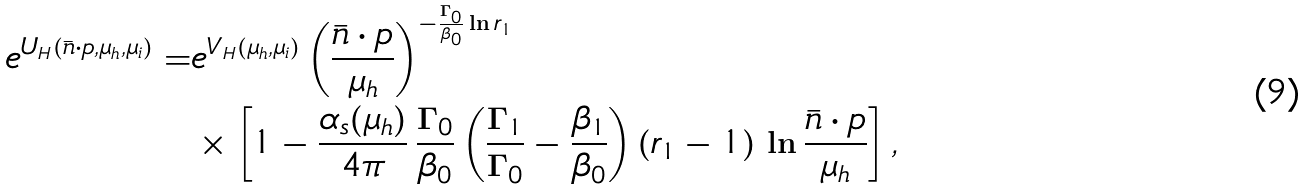<formula> <loc_0><loc_0><loc_500><loc_500>e ^ { U _ { H } ( \bar { n } \cdot p , \mu _ { h } , \mu _ { i } ) } = & e ^ { V _ { H } ( \mu _ { h } , \mu _ { i } ) } \left ( \frac { \bar { n } \cdot p } { \mu _ { h } } \right ) ^ { - \frac { \Gamma _ { 0 } } { \beta _ { 0 } } \ln r _ { 1 } } \\ & \times \left [ 1 - \frac { \alpha _ { s } ( \mu _ { h } ) } { 4 \pi } \, \frac { \Gamma _ { 0 } } { \beta _ { 0 } } \left ( \frac { \Gamma _ { 1 } } { \Gamma _ { 0 } } - \frac { \beta _ { 1 } } { \beta _ { 0 } } \right ) ( r _ { 1 } - 1 ) \, \ln \frac { \bar { n } \cdot p } { \mu _ { h } } \right ] ,</formula> 